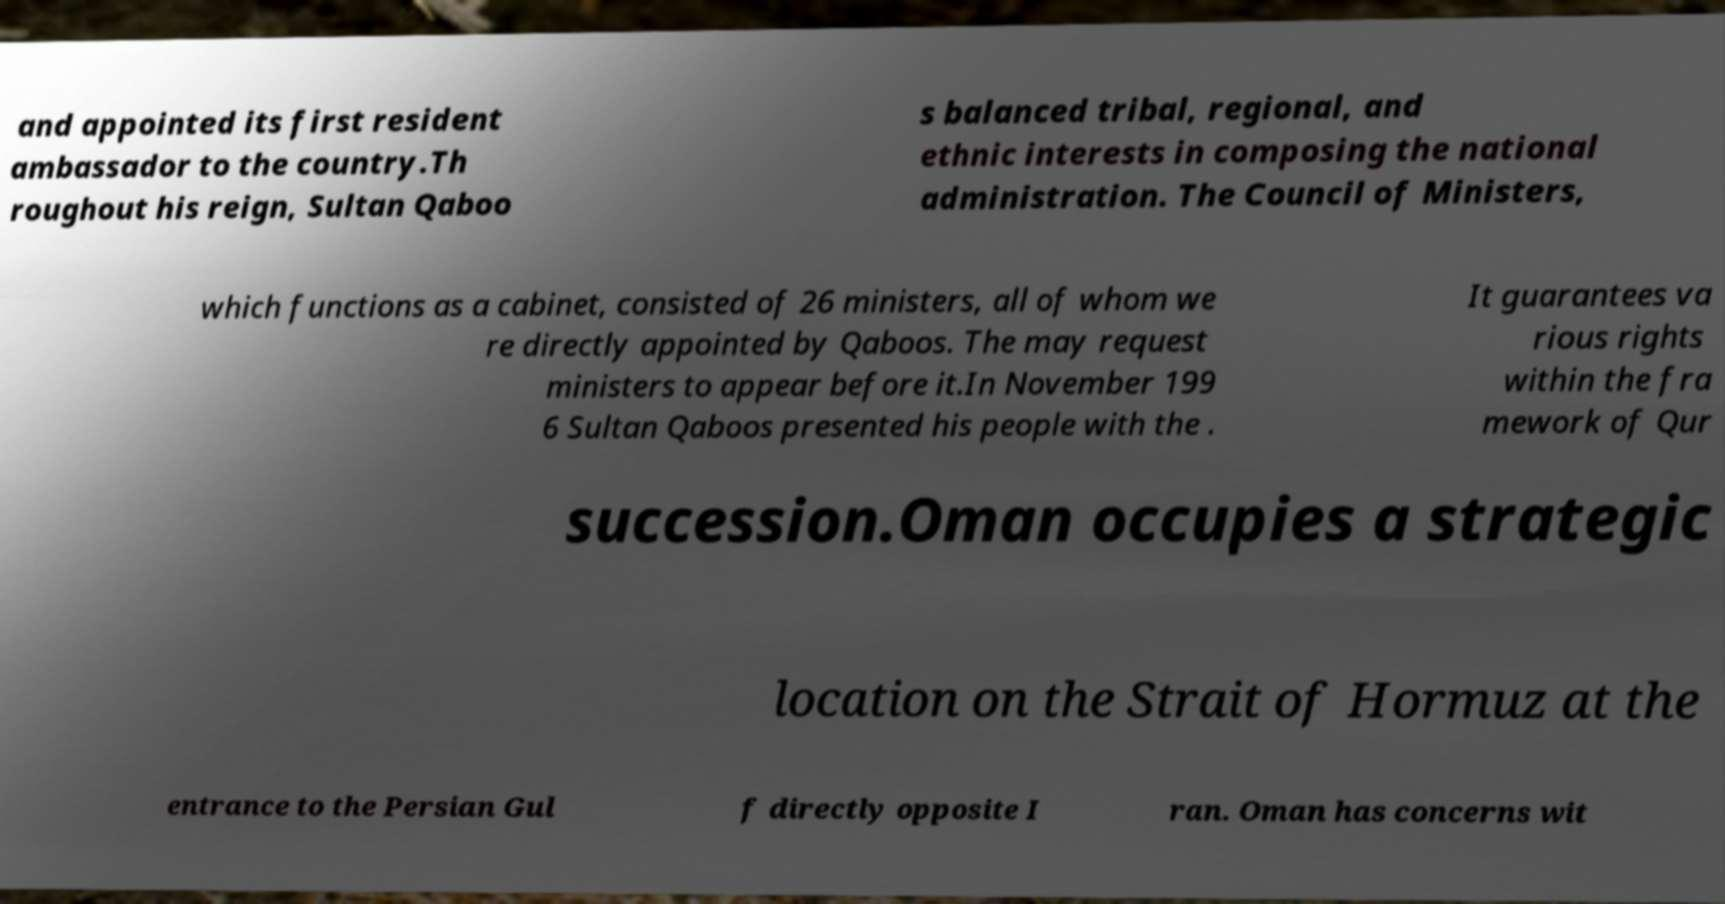Could you extract and type out the text from this image? and appointed its first resident ambassador to the country.Th roughout his reign, Sultan Qaboo s balanced tribal, regional, and ethnic interests in composing the national administration. The Council of Ministers, which functions as a cabinet, consisted of 26 ministers, all of whom we re directly appointed by Qaboos. The may request ministers to appear before it.In November 199 6 Sultan Qaboos presented his people with the . It guarantees va rious rights within the fra mework of Qur succession.Oman occupies a strategic location on the Strait of Hormuz at the entrance to the Persian Gul f directly opposite I ran. Oman has concerns wit 